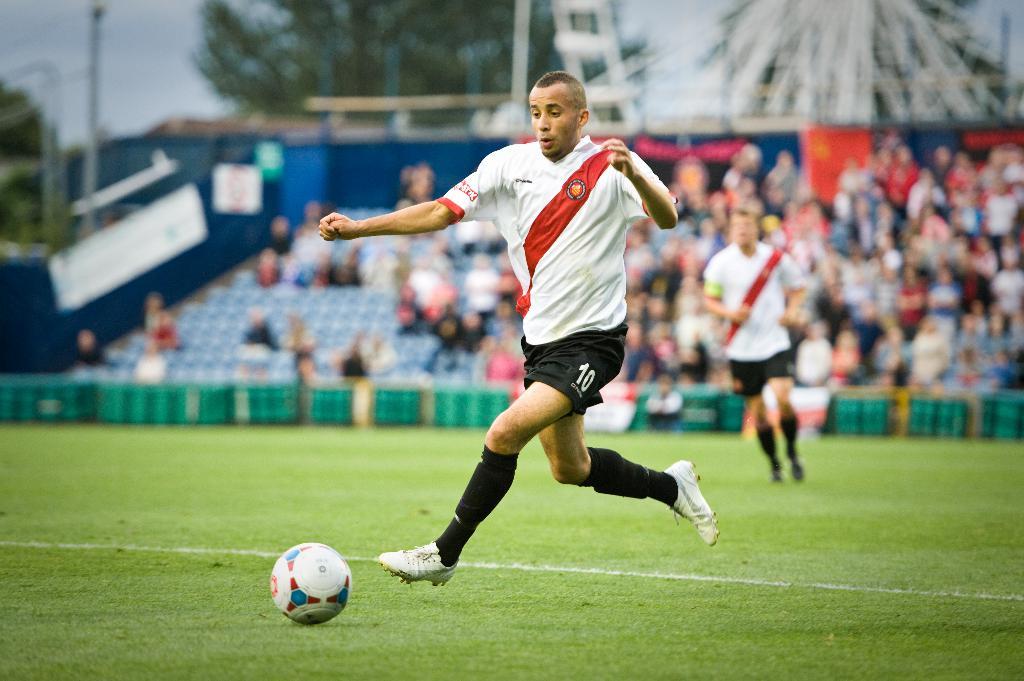What player number is controlling the ball?
Offer a terse response. 10. 